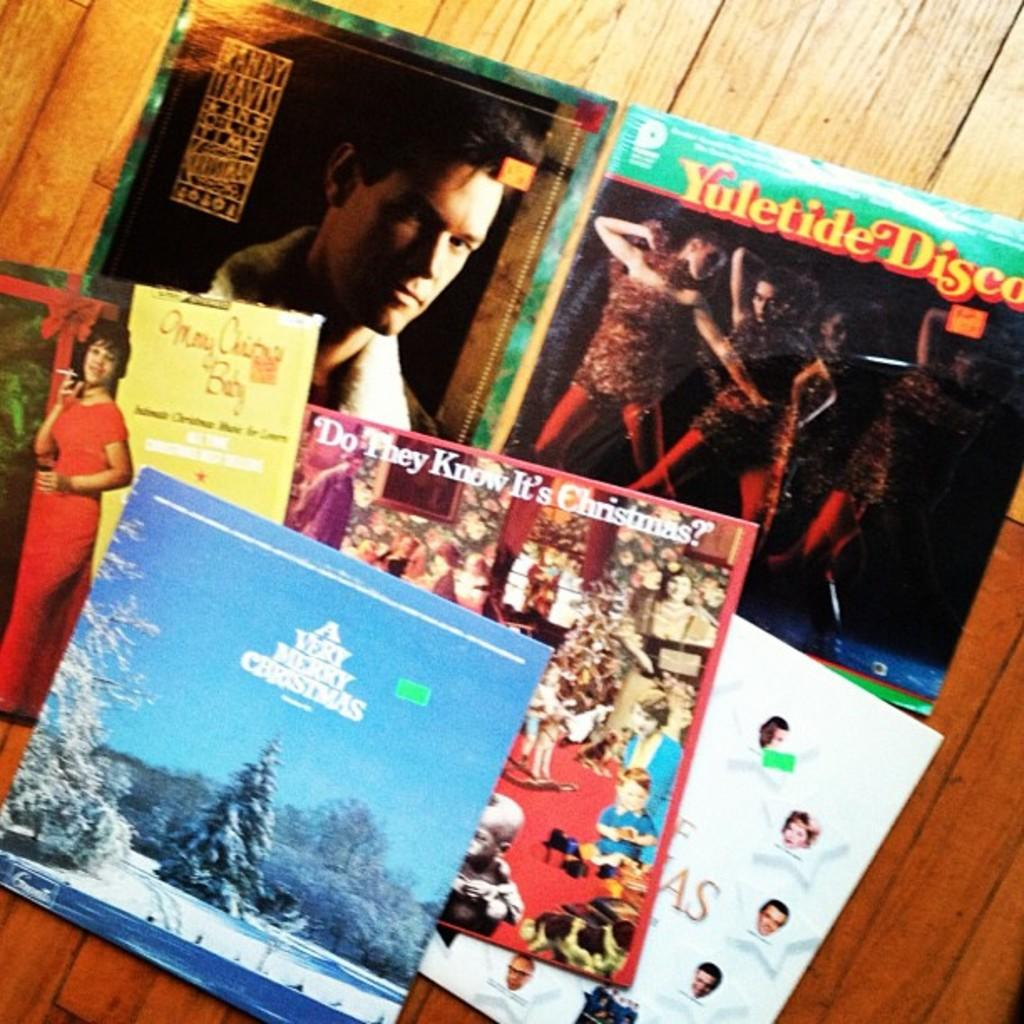<image>
Relay a brief, clear account of the picture shown. A collection of albums includes A Very Merry Christmas. 